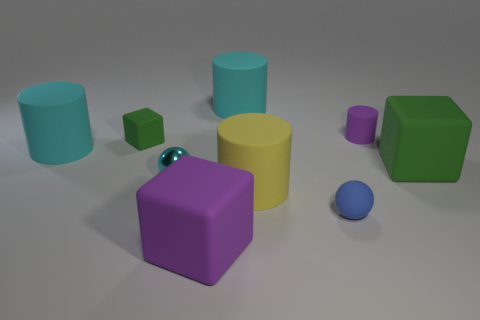Subtract all green cubes. How many were subtracted if there are1green cubes left? 1 Subtract all tiny cylinders. How many cylinders are left? 3 Add 1 cylinders. How many objects exist? 10 Subtract all yellow cylinders. How many cylinders are left? 3 Subtract all cylinders. How many objects are left? 5 Subtract 2 balls. How many balls are left? 0 Subtract all yellow spheres. Subtract all yellow cylinders. How many spheres are left? 2 Subtract all green cubes. How many gray balls are left? 0 Subtract all small cyan metal balls. Subtract all large cyan things. How many objects are left? 6 Add 5 small cyan objects. How many small cyan objects are left? 6 